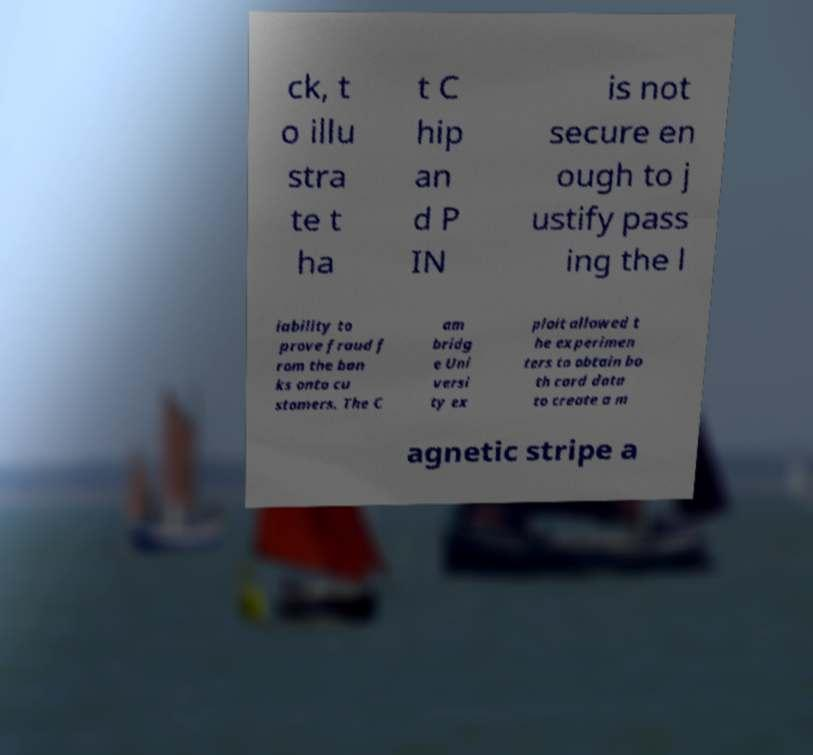Please identify and transcribe the text found in this image. ck, t o illu stra te t ha t C hip an d P IN is not secure en ough to j ustify pass ing the l iability to prove fraud f rom the ban ks onto cu stomers. The C am bridg e Uni versi ty ex ploit allowed t he experimen ters to obtain bo th card data to create a m agnetic stripe a 